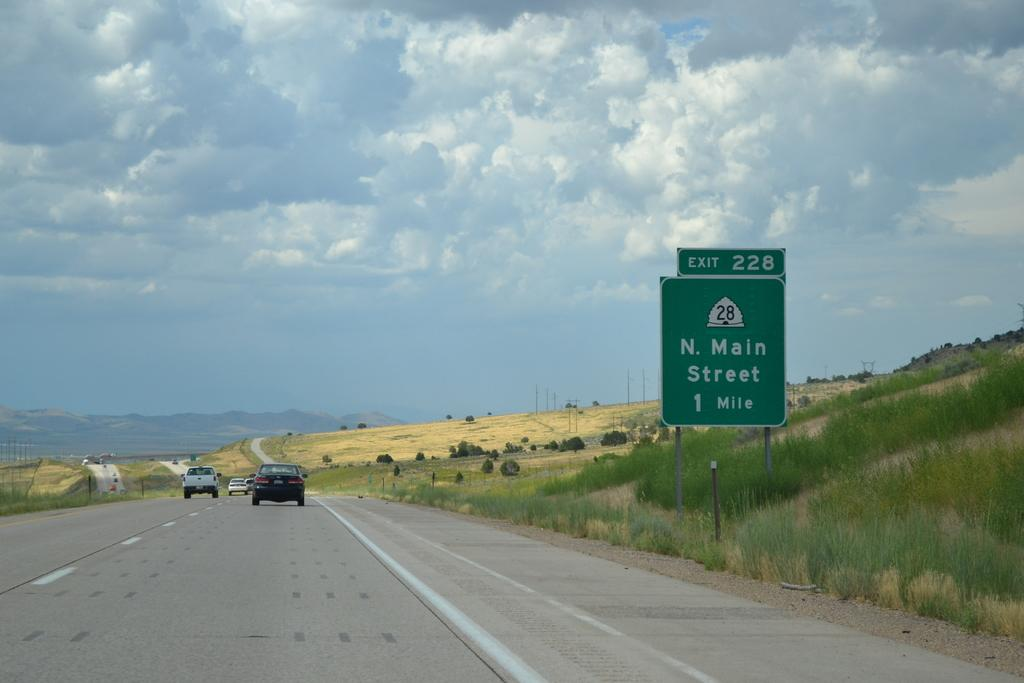<image>
Offer a succinct explanation of the picture presented. A sign for N. Main Street says that it is one mile away. 